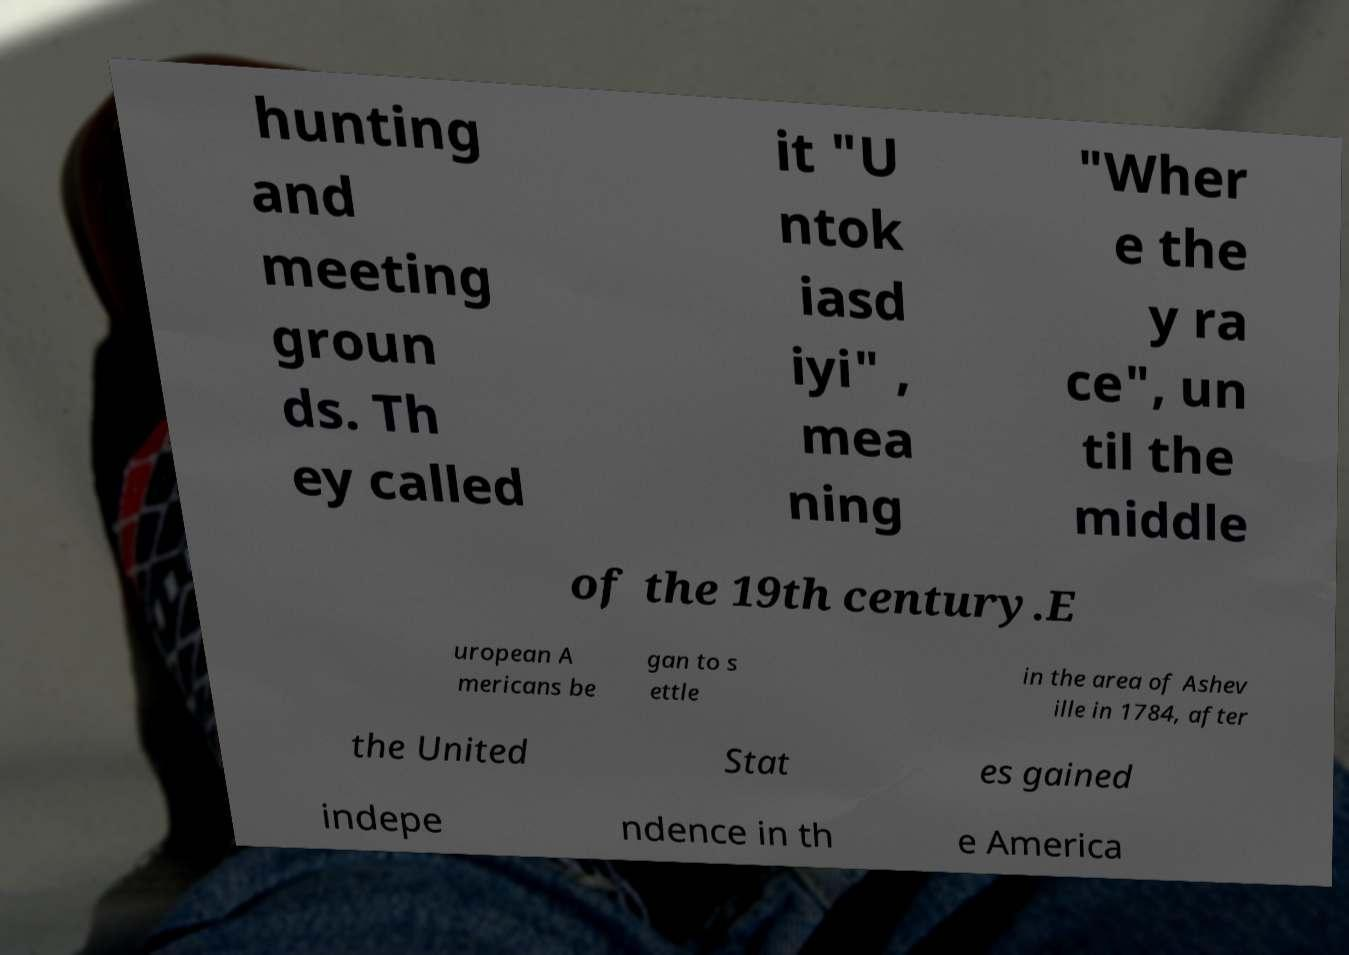Can you accurately transcribe the text from the provided image for me? hunting and meeting groun ds. Th ey called it "U ntok iasd iyi" , mea ning "Wher e the y ra ce", un til the middle of the 19th century.E uropean A mericans be gan to s ettle in the area of Ashev ille in 1784, after the United Stat es gained indepe ndence in th e America 